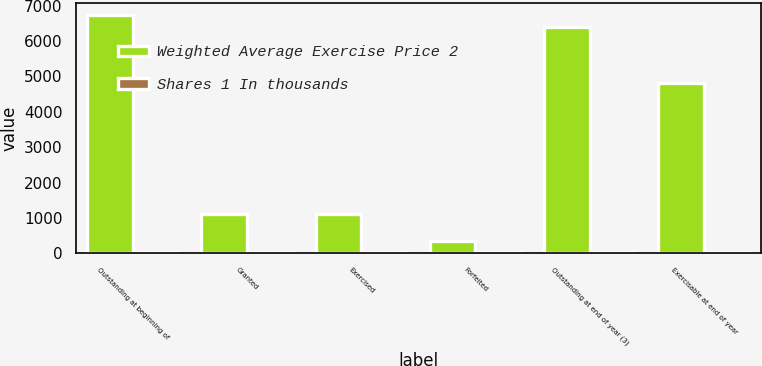Convert chart. <chart><loc_0><loc_0><loc_500><loc_500><stacked_bar_chart><ecel><fcel>Outstanding at beginning of<fcel>Granted<fcel>Exercised<fcel>Forfeited<fcel>Outstanding at end of year (3)<fcel>Exercisable at end of year<nl><fcel>Weighted Average Exercise Price 2<fcel>6749<fcel>1126<fcel>1121<fcel>363<fcel>6391<fcel>4829<nl><fcel>Shares 1 In thousands<fcel>41<fcel>43<fcel>34<fcel>45<fcel>42<fcel>42<nl></chart> 